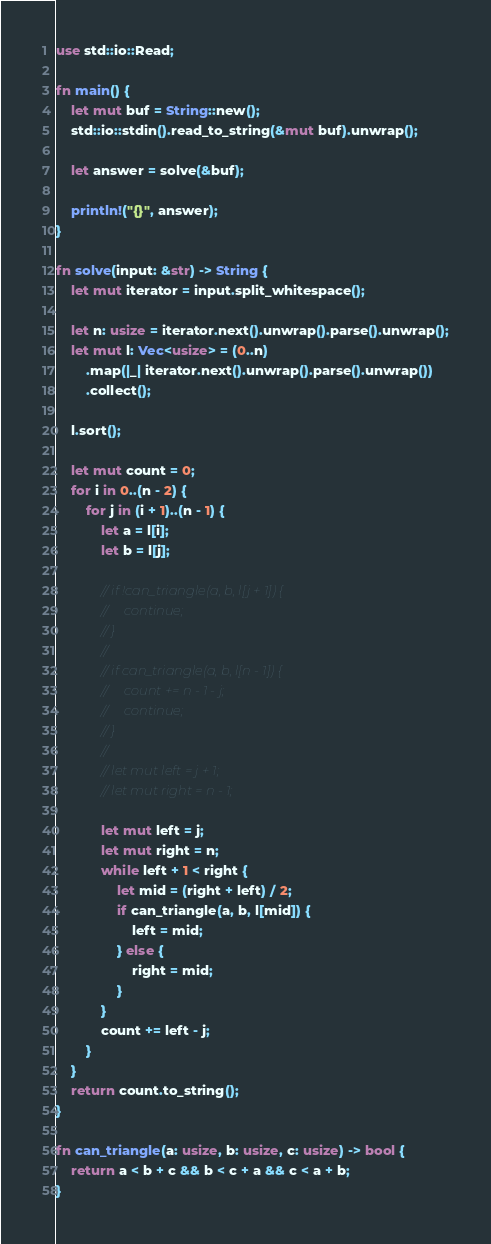<code> <loc_0><loc_0><loc_500><loc_500><_Rust_>use std::io::Read;

fn main() {
    let mut buf = String::new();
    std::io::stdin().read_to_string(&mut buf).unwrap();

    let answer = solve(&buf);

    println!("{}", answer);
}

fn solve(input: &str) -> String {
    let mut iterator = input.split_whitespace();

    let n: usize = iterator.next().unwrap().parse().unwrap();
    let mut l: Vec<usize> = (0..n)
        .map(|_| iterator.next().unwrap().parse().unwrap())
        .collect();

    l.sort();

    let mut count = 0;
    for i in 0..(n - 2) {
        for j in (i + 1)..(n - 1) {
            let a = l[i];
            let b = l[j];

            // if !can_triangle(a, b, l[j + 1]) {
            //     continue;
            // }
            //
            // if can_triangle(a, b, l[n - 1]) {
            //     count += n - 1 - j;
            //     continue;
            // }
            //
            // let mut left = j + 1;
            // let mut right = n - 1;

            let mut left = j;
            let mut right = n;
            while left + 1 < right {
                let mid = (right + left) / 2;
                if can_triangle(a, b, l[mid]) {
                    left = mid;
                } else {
                    right = mid;
                }
            }
            count += left - j;
        }
    }
    return count.to_string();
}

fn can_triangle(a: usize, b: usize, c: usize) -> bool {
    return a < b + c && b < c + a && c < a + b;
}
</code> 